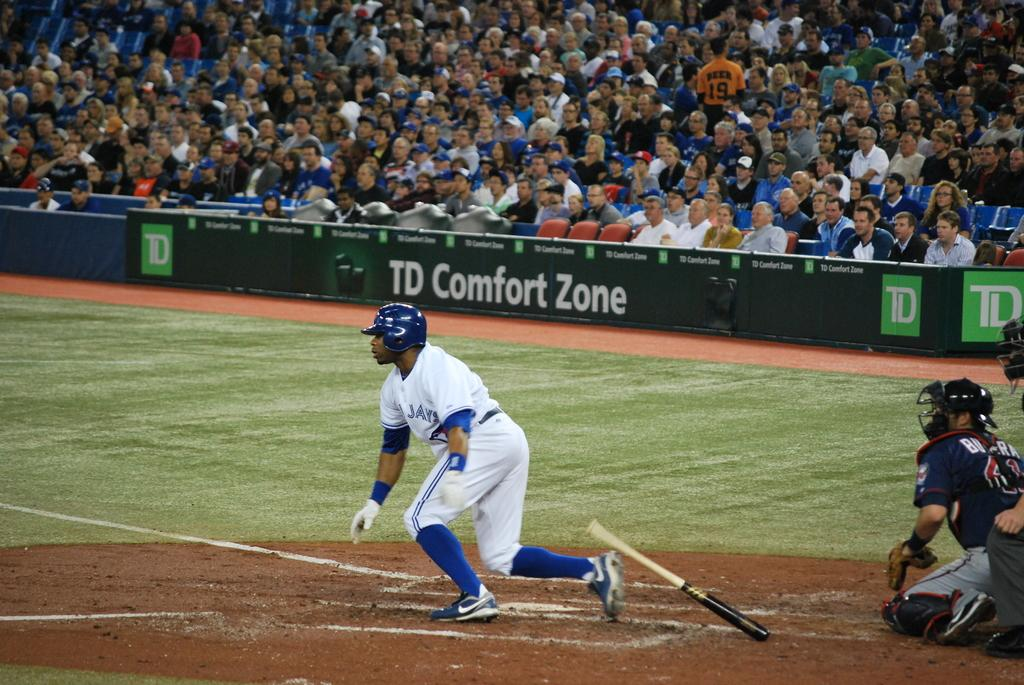<image>
Write a terse but informative summary of the picture. An ad for "TD Comfort Zone" is in the baseball field. 